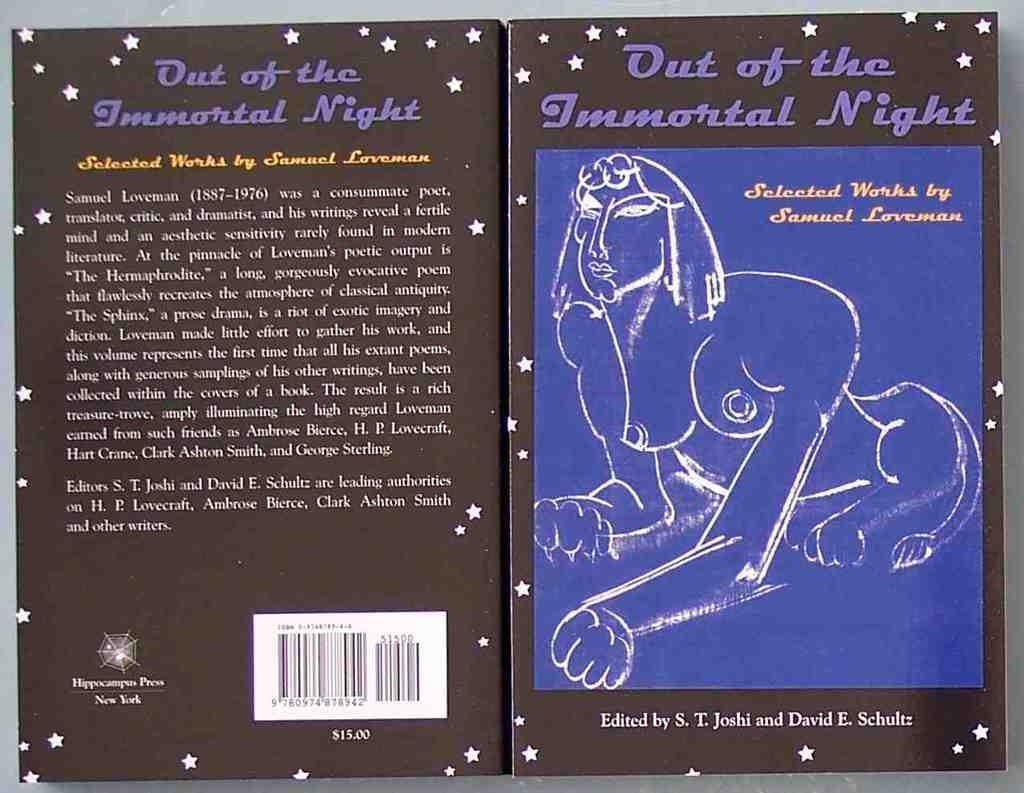<image>
Relay a brief, clear account of the picture shown. A book with a naked Spinx on the cover is the selected works of Samual Loveman. 